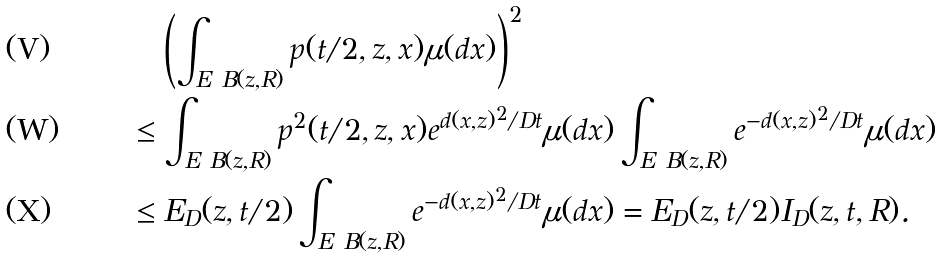Convert formula to latex. <formula><loc_0><loc_0><loc_500><loc_500>& \quad \left ( \int _ { E \ B ( z , R ) } p ( t / 2 , z , x ) \mu ( d x ) \right ) ^ { 2 } \\ & \leq \int _ { E \ B ( z , R ) } p ^ { 2 } ( t / 2 , z , x ) e ^ { d ( x , z ) ^ { 2 } / D t } \mu ( d x ) \int _ { E \ B ( z , R ) } e ^ { - d ( x , z ) ^ { 2 } / D t } \mu ( d x ) \\ & \leq E _ { D } ( z , t / 2 ) \int _ { E \ B ( z , R ) } e ^ { - d ( x , z ) ^ { 2 } / D t } \mu ( d x ) = E _ { D } ( z , t / 2 ) I _ { D } ( z , t , R ) .</formula> 